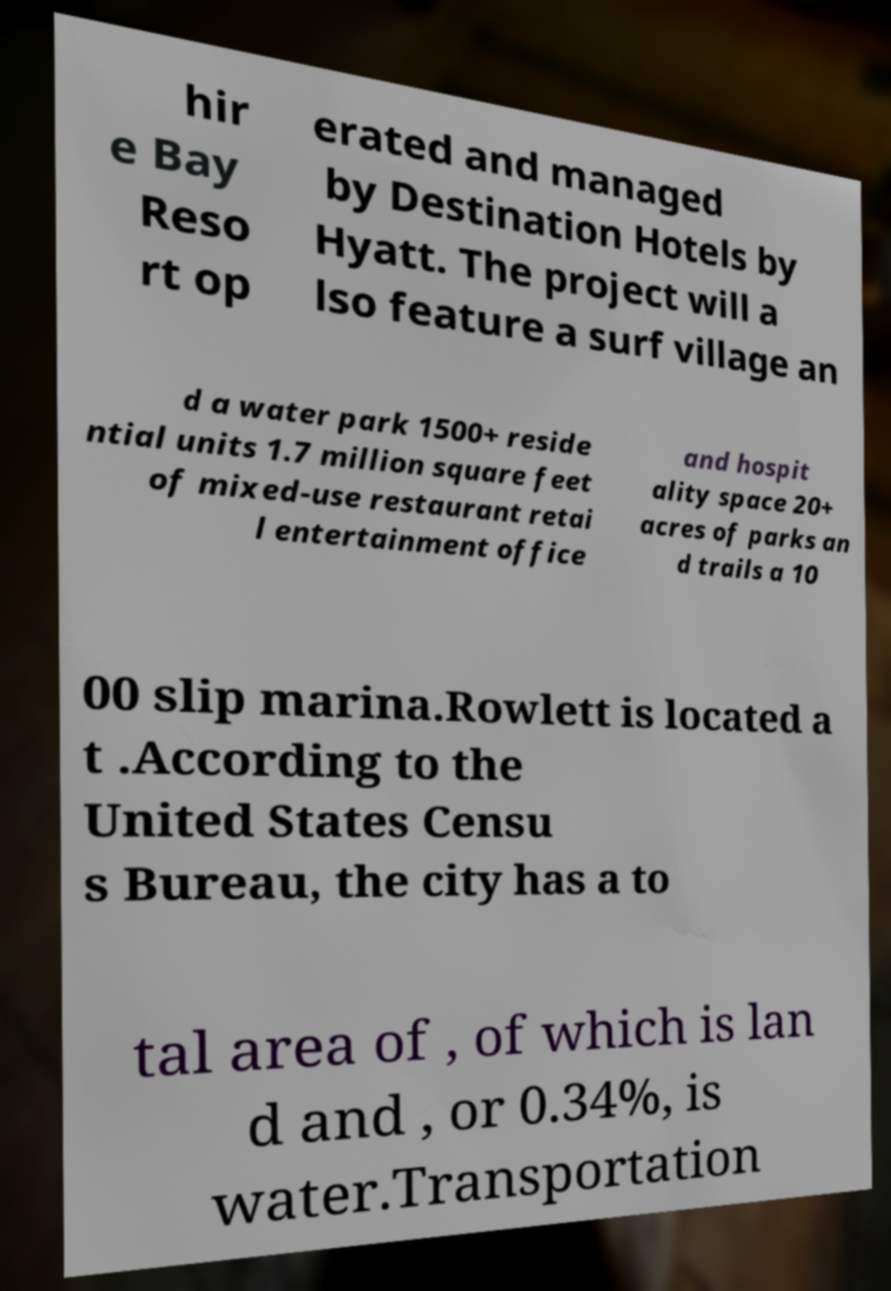Can you accurately transcribe the text from the provided image for me? hir e Bay Reso rt op erated and managed by Destination Hotels by Hyatt. The project will a lso feature a surf village an d a water park 1500+ reside ntial units 1.7 million square feet of mixed-use restaurant retai l entertainment office and hospit ality space 20+ acres of parks an d trails a 10 00 slip marina.Rowlett is located a t .According to the United States Censu s Bureau, the city has a to tal area of , of which is lan d and , or 0.34%, is water.Transportation 